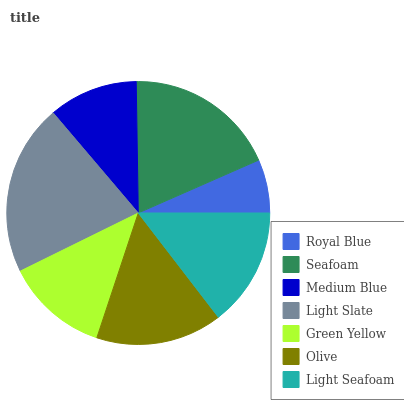Is Royal Blue the minimum?
Answer yes or no. Yes. Is Light Slate the maximum?
Answer yes or no. Yes. Is Seafoam the minimum?
Answer yes or no. No. Is Seafoam the maximum?
Answer yes or no. No. Is Seafoam greater than Royal Blue?
Answer yes or no. Yes. Is Royal Blue less than Seafoam?
Answer yes or no. Yes. Is Royal Blue greater than Seafoam?
Answer yes or no. No. Is Seafoam less than Royal Blue?
Answer yes or no. No. Is Light Seafoam the high median?
Answer yes or no. Yes. Is Light Seafoam the low median?
Answer yes or no. Yes. Is Seafoam the high median?
Answer yes or no. No. Is Green Yellow the low median?
Answer yes or no. No. 